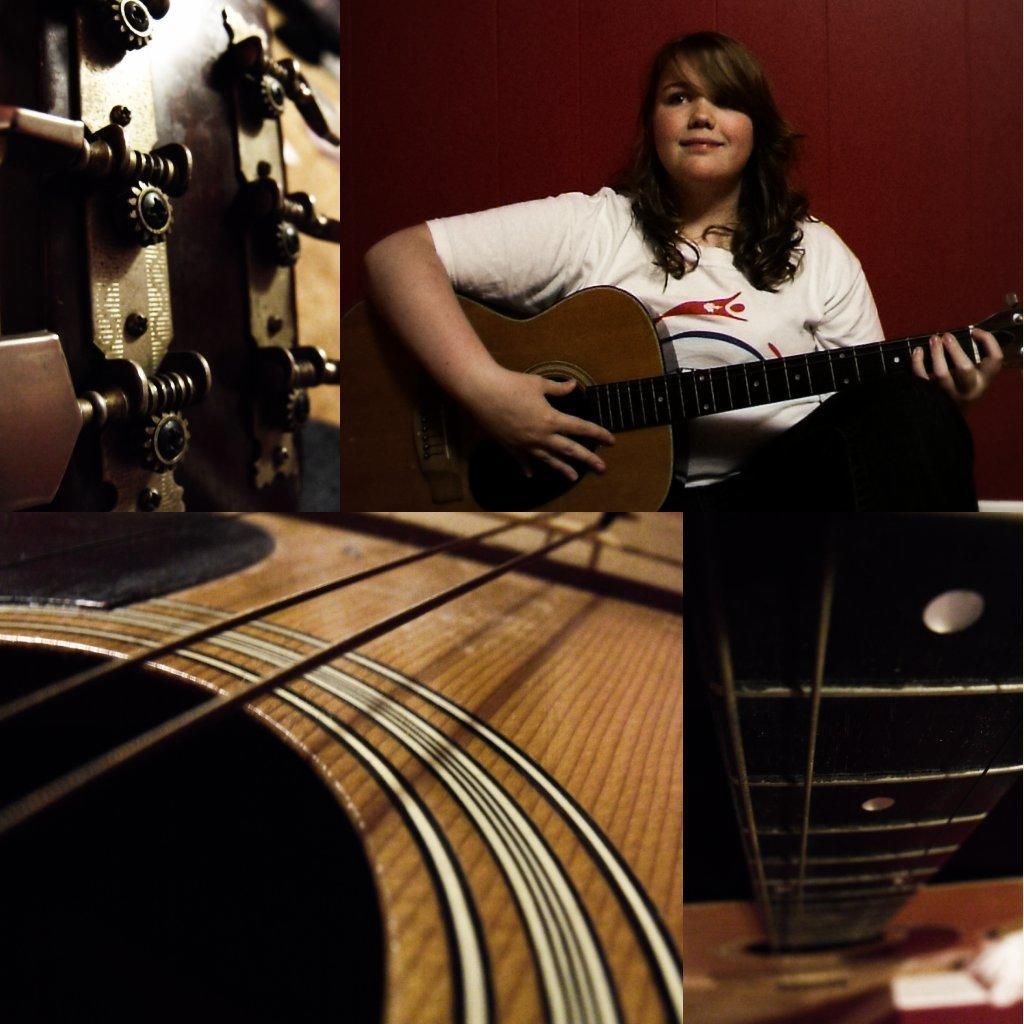In one or two sentences, can you explain what this image depicts? This is a collage. On the right to a lady is playing guitar. She is smiling. She is wearing a white t-shirt. On the other three image there are parts of guitar. 